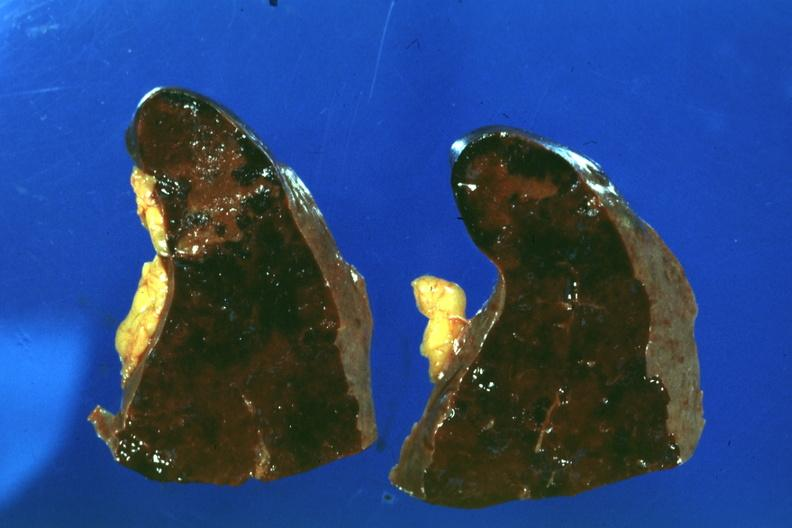what does this image show?
Answer the question using a single word or phrase. Congested spleen infarct easily seen 